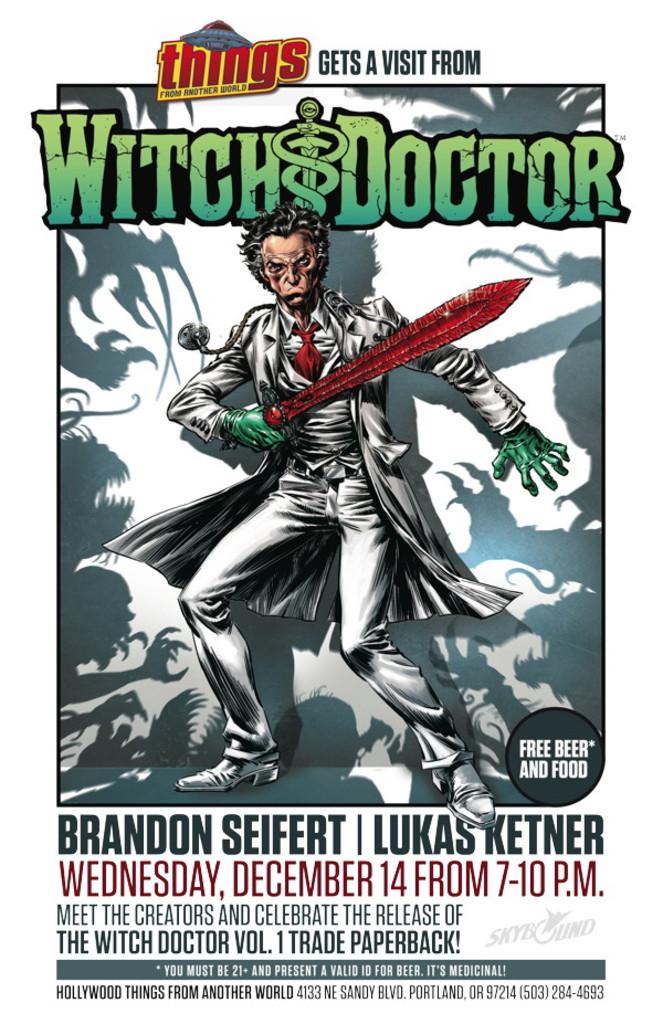What can you get for free at this event?
Provide a succinct answer. Beer and food. What day is this event on?
Make the answer very short. Wednesday. 